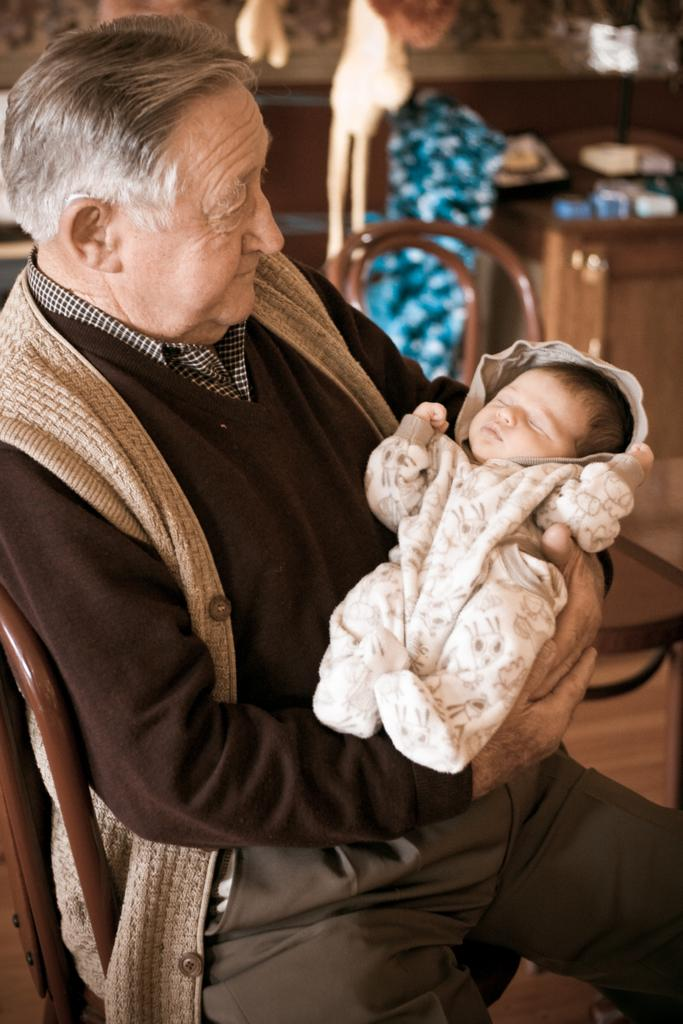What is the man in the image doing? The man is seated on a chair in the image, and he is holding a baby in his hand. Can you describe the chair the man is sitting on? There is another chair in the image, but the man is seated on a different chair. What can be seen on the back of the chair? There are items visible on the back of the chair. How does the kitty react to the crowd in the image? There is no kitty or crowd present in the image. Why is the baby crying in the image? The baby is not crying in the image; it is being held by the man. 